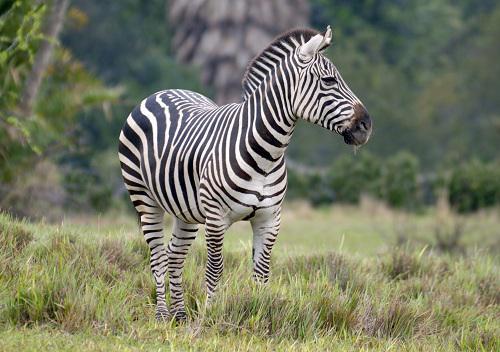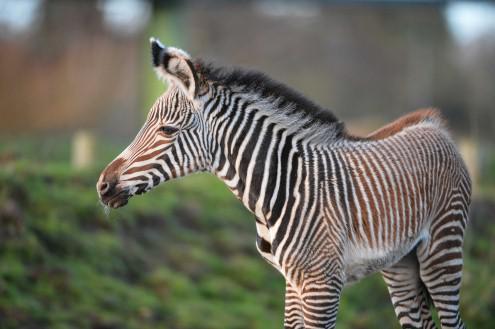The first image is the image on the left, the second image is the image on the right. For the images shown, is this caption "The zebras in both pictures are facing left." true? Answer yes or no. No. The first image is the image on the left, the second image is the image on the right. Evaluate the accuracy of this statement regarding the images: "There is a baby zebra standing next to an adult zebra.". Is it true? Answer yes or no. No. 